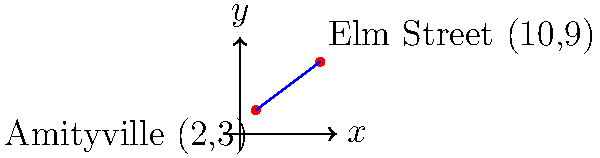As a horror movie enthusiast, you're mapping iconic film locations. The Amityville house is located at coordinates (2,3), while the house on Elm Street is at (10,9). Find the equation of the line connecting these two legendary horror locations in slope-intercept form $(y = mx + b)$. Let's approach this step-by-step:

1) First, we need to find the slope (m) of the line. We can use the slope formula:

   $m = \frac{y_2 - y_1}{x_2 - x_1}$

   Where $(x_1, y_1)$ is Amityville (2,3) and $(x_2, y_2)$ is Elm Street (10,9).

2) Plugging in the values:

   $m = \frac{9 - 3}{10 - 2} = \frac{6}{8} = \frac{3}{4}$

3) Now that we have the slope, we can use the point-slope form of a line:

   $y - y_1 = m(x - x_1)$

4) Let's use the Amityville point (2,3). Plugging in the values:

   $y - 3 = \frac{3}{4}(x - 2)$

5) To get to slope-intercept form $(y = mx + b)$, we need to distribute the $\frac{3}{4}$ and isolate y:

   $y - 3 = \frac{3}{4}x - \frac{3}{2}$
   $y = \frac{3}{4}x - \frac{3}{2} + 3$
   $y = \frac{3}{4}x + \frac{3}{2}$

6) Therefore, the equation of the line in slope-intercept form is:

   $y = \frac{3}{4}x + \frac{3}{2}$
Answer: $y = \frac{3}{4}x + \frac{3}{2}$ 